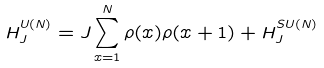<formula> <loc_0><loc_0><loc_500><loc_500>H _ { J } ^ { U ( N ) } = J \sum _ { x = 1 } ^ { N } \rho ( x ) \rho ( x + 1 ) + H _ { J } ^ { S U ( N ) }</formula> 